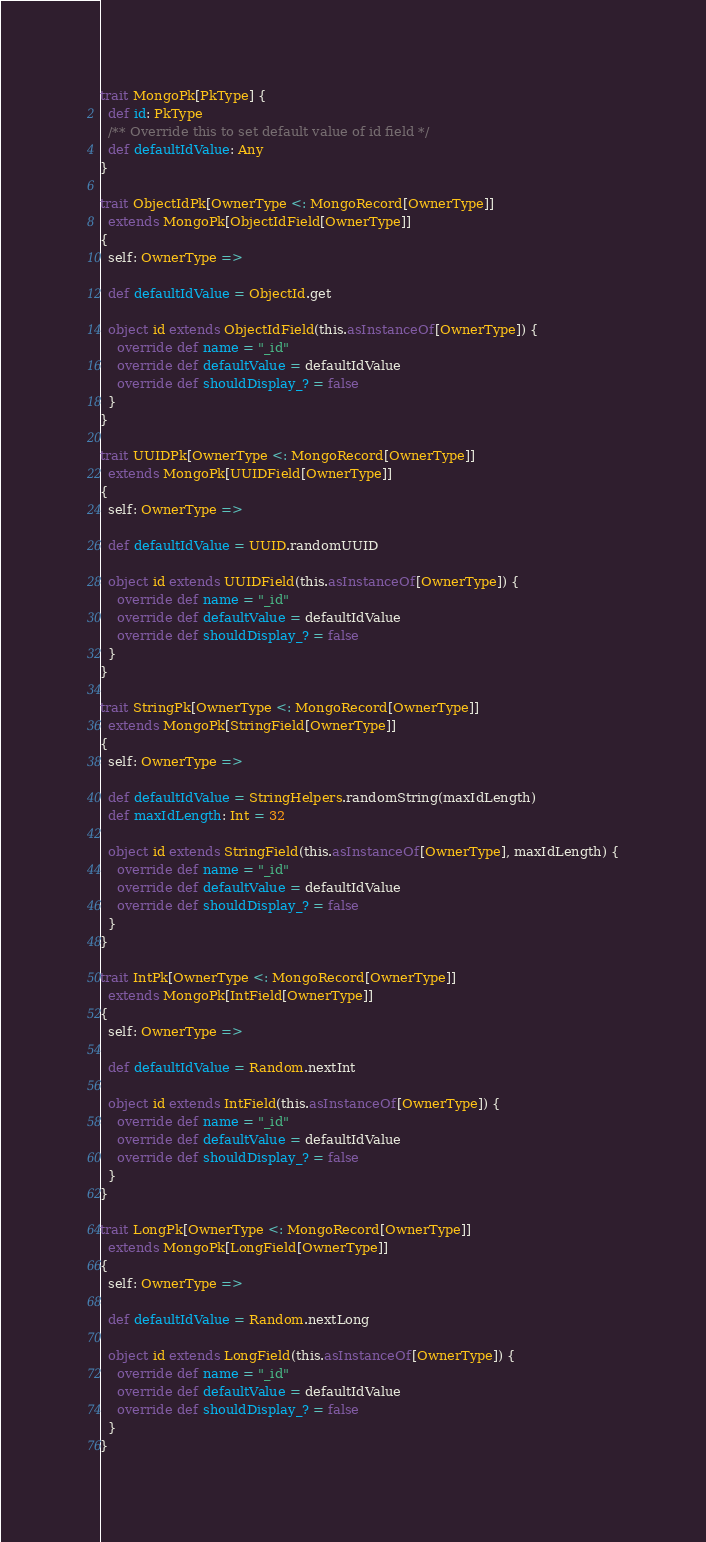Convert code to text. <code><loc_0><loc_0><loc_500><loc_500><_Scala_>trait MongoPk[PkType] {
  def id: PkType
  /** Override this to set default value of id field */
  def defaultIdValue: Any
}

trait ObjectIdPk[OwnerType <: MongoRecord[OwnerType]]
  extends MongoPk[ObjectIdField[OwnerType]]
{
  self: OwnerType =>

  def defaultIdValue = ObjectId.get

  object id extends ObjectIdField(this.asInstanceOf[OwnerType]) {
    override def name = "_id"
    override def defaultValue = defaultIdValue
    override def shouldDisplay_? = false
  }
}

trait UUIDPk[OwnerType <: MongoRecord[OwnerType]]
  extends MongoPk[UUIDField[OwnerType]]
{
  self: OwnerType =>

  def defaultIdValue = UUID.randomUUID

  object id extends UUIDField(this.asInstanceOf[OwnerType]) {
    override def name = "_id"
    override def defaultValue = defaultIdValue
    override def shouldDisplay_? = false
  }
}

trait StringPk[OwnerType <: MongoRecord[OwnerType]]
  extends MongoPk[StringField[OwnerType]]
{
  self: OwnerType =>

  def defaultIdValue = StringHelpers.randomString(maxIdLength)
  def maxIdLength: Int = 32

  object id extends StringField(this.asInstanceOf[OwnerType], maxIdLength) {
    override def name = "_id"
    override def defaultValue = defaultIdValue
    override def shouldDisplay_? = false
  }
}

trait IntPk[OwnerType <: MongoRecord[OwnerType]]
  extends MongoPk[IntField[OwnerType]]
{
  self: OwnerType =>

  def defaultIdValue = Random.nextInt

  object id extends IntField(this.asInstanceOf[OwnerType]) {
    override def name = "_id"
    override def defaultValue = defaultIdValue
    override def shouldDisplay_? = false
  }
}

trait LongPk[OwnerType <: MongoRecord[OwnerType]]
  extends MongoPk[LongField[OwnerType]]
{
  self: OwnerType =>

  def defaultIdValue = Random.nextLong

  object id extends LongField(this.asInstanceOf[OwnerType]) {
    override def name = "_id"
    override def defaultValue = defaultIdValue
    override def shouldDisplay_? = false
  }
}
</code> 